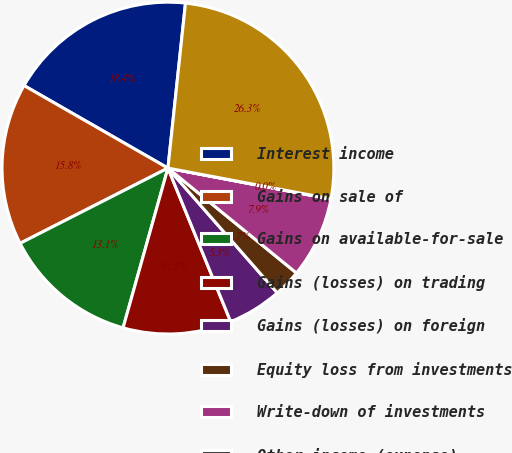<chart> <loc_0><loc_0><loc_500><loc_500><pie_chart><fcel>Interest income<fcel>Gains on sale of<fcel>Gains on available-for-sale<fcel>Gains (losses) on trading<fcel>Gains (losses) on foreign<fcel>Equity loss from investments<fcel>Write-down of investments<fcel>Other income (expense)<fcel>Total other income (expense)<nl><fcel>18.4%<fcel>15.78%<fcel>13.15%<fcel>10.53%<fcel>5.28%<fcel>2.65%<fcel>7.9%<fcel>0.03%<fcel>26.28%<nl></chart> 